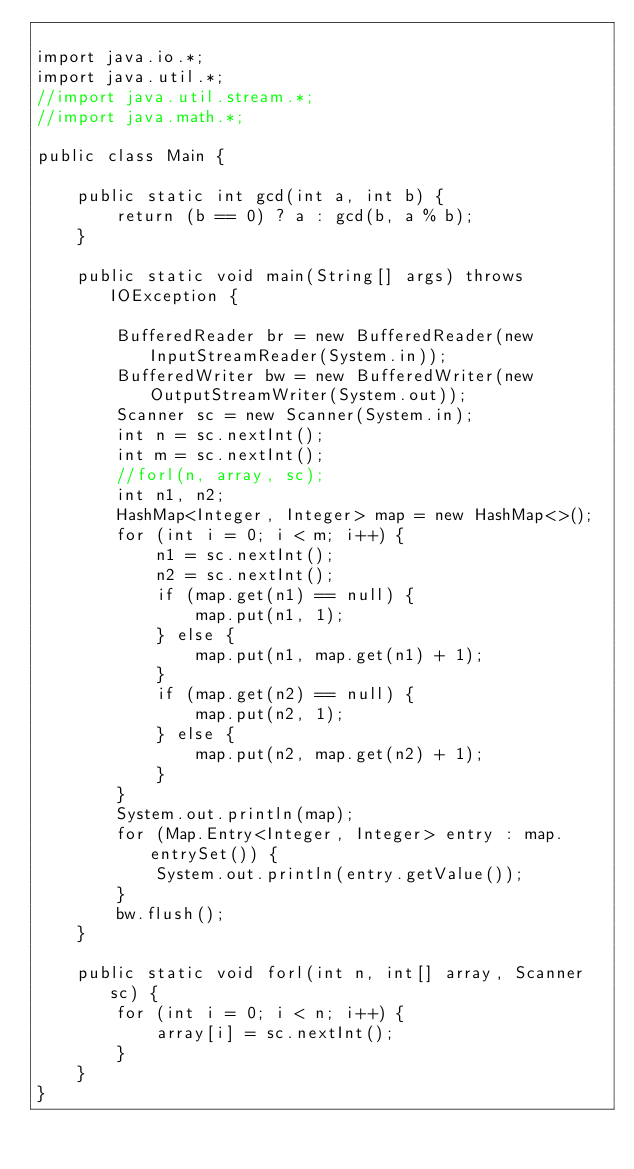<code> <loc_0><loc_0><loc_500><loc_500><_Java_>
import java.io.*;
import java.util.*;
//import java.util.stream.*;
//import java.math.*;

public class Main {

    public static int gcd(int a, int b) {
        return (b == 0) ? a : gcd(b, a % b);
    }

    public static void main(String[] args) throws IOException {

        BufferedReader br = new BufferedReader(new InputStreamReader(System.in));
        BufferedWriter bw = new BufferedWriter(new OutputStreamWriter(System.out));
        Scanner sc = new Scanner(System.in);
        int n = sc.nextInt();
        int m = sc.nextInt();
        //forl(n, array, sc);
        int n1, n2;
        HashMap<Integer, Integer> map = new HashMap<>();
        for (int i = 0; i < m; i++) {
            n1 = sc.nextInt();
            n2 = sc.nextInt();
            if (map.get(n1) == null) {
                map.put(n1, 1);
            } else {
                map.put(n1, map.get(n1) + 1);
            }
            if (map.get(n2) == null) {
                map.put(n2, 1);
            } else {
                map.put(n2, map.get(n2) + 1);
            }
        }
        System.out.println(map);
        for (Map.Entry<Integer, Integer> entry : map.entrySet()) {
            System.out.println(entry.getValue());
        }
        bw.flush();
    }

    public static void forl(int n, int[] array, Scanner sc) {
        for (int i = 0; i < n; i++) {
            array[i] = sc.nextInt();
        }
    }
}
</code> 